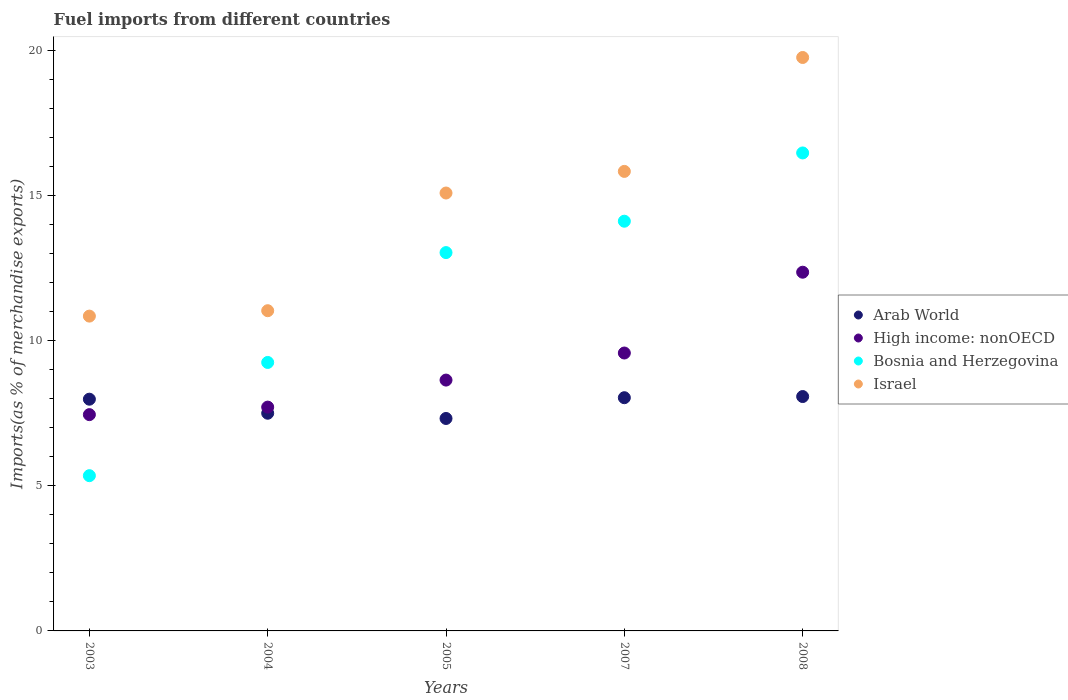Is the number of dotlines equal to the number of legend labels?
Provide a short and direct response. Yes. What is the percentage of imports to different countries in Arab World in 2003?
Offer a terse response. 7.98. Across all years, what is the maximum percentage of imports to different countries in Arab World?
Give a very brief answer. 8.07. Across all years, what is the minimum percentage of imports to different countries in Israel?
Make the answer very short. 10.85. In which year was the percentage of imports to different countries in Israel maximum?
Your answer should be very brief. 2008. In which year was the percentage of imports to different countries in Bosnia and Herzegovina minimum?
Your response must be concise. 2003. What is the total percentage of imports to different countries in High income: nonOECD in the graph?
Provide a succinct answer. 45.73. What is the difference between the percentage of imports to different countries in Arab World in 2004 and that in 2005?
Your answer should be compact. 0.18. What is the difference between the percentage of imports to different countries in Israel in 2005 and the percentage of imports to different countries in High income: nonOECD in 2008?
Offer a very short reply. 2.73. What is the average percentage of imports to different countries in Israel per year?
Your answer should be compact. 14.51. In the year 2005, what is the difference between the percentage of imports to different countries in Israel and percentage of imports to different countries in Arab World?
Make the answer very short. 7.77. In how many years, is the percentage of imports to different countries in High income: nonOECD greater than 15 %?
Offer a very short reply. 0. What is the ratio of the percentage of imports to different countries in Bosnia and Herzegovina in 2003 to that in 2008?
Your answer should be very brief. 0.32. What is the difference between the highest and the second highest percentage of imports to different countries in Israel?
Provide a succinct answer. 3.92. What is the difference between the highest and the lowest percentage of imports to different countries in Israel?
Your answer should be very brief. 8.91. In how many years, is the percentage of imports to different countries in Israel greater than the average percentage of imports to different countries in Israel taken over all years?
Offer a terse response. 3. Is the sum of the percentage of imports to different countries in Bosnia and Herzegovina in 2004 and 2005 greater than the maximum percentage of imports to different countries in Israel across all years?
Keep it short and to the point. Yes. Is it the case that in every year, the sum of the percentage of imports to different countries in Israel and percentage of imports to different countries in High income: nonOECD  is greater than the sum of percentage of imports to different countries in Bosnia and Herzegovina and percentage of imports to different countries in Arab World?
Provide a short and direct response. Yes. Is the percentage of imports to different countries in Arab World strictly less than the percentage of imports to different countries in High income: nonOECD over the years?
Offer a very short reply. No. How many dotlines are there?
Keep it short and to the point. 4. Are the values on the major ticks of Y-axis written in scientific E-notation?
Your response must be concise. No. Does the graph contain any zero values?
Your answer should be compact. No. Where does the legend appear in the graph?
Your answer should be very brief. Center right. How are the legend labels stacked?
Ensure brevity in your answer.  Vertical. What is the title of the graph?
Offer a terse response. Fuel imports from different countries. What is the label or title of the X-axis?
Ensure brevity in your answer.  Years. What is the label or title of the Y-axis?
Give a very brief answer. Imports(as % of merchandise exports). What is the Imports(as % of merchandise exports) in Arab World in 2003?
Make the answer very short. 7.98. What is the Imports(as % of merchandise exports) of High income: nonOECD in 2003?
Offer a very short reply. 7.45. What is the Imports(as % of merchandise exports) in Bosnia and Herzegovina in 2003?
Make the answer very short. 5.35. What is the Imports(as % of merchandise exports) of Israel in 2003?
Your answer should be very brief. 10.85. What is the Imports(as % of merchandise exports) of Arab World in 2004?
Offer a terse response. 7.5. What is the Imports(as % of merchandise exports) of High income: nonOECD in 2004?
Give a very brief answer. 7.71. What is the Imports(as % of merchandise exports) in Bosnia and Herzegovina in 2004?
Ensure brevity in your answer.  9.25. What is the Imports(as % of merchandise exports) in Israel in 2004?
Provide a short and direct response. 11.03. What is the Imports(as % of merchandise exports) in Arab World in 2005?
Provide a short and direct response. 7.32. What is the Imports(as % of merchandise exports) in High income: nonOECD in 2005?
Offer a terse response. 8.64. What is the Imports(as % of merchandise exports) of Bosnia and Herzegovina in 2005?
Provide a short and direct response. 13.03. What is the Imports(as % of merchandise exports) in Israel in 2005?
Your answer should be very brief. 15.09. What is the Imports(as % of merchandise exports) in Arab World in 2007?
Your answer should be compact. 8.03. What is the Imports(as % of merchandise exports) of High income: nonOECD in 2007?
Your response must be concise. 9.57. What is the Imports(as % of merchandise exports) in Bosnia and Herzegovina in 2007?
Give a very brief answer. 14.11. What is the Imports(as % of merchandise exports) of Israel in 2007?
Ensure brevity in your answer.  15.83. What is the Imports(as % of merchandise exports) in Arab World in 2008?
Your answer should be compact. 8.07. What is the Imports(as % of merchandise exports) in High income: nonOECD in 2008?
Provide a succinct answer. 12.36. What is the Imports(as % of merchandise exports) of Bosnia and Herzegovina in 2008?
Give a very brief answer. 16.47. What is the Imports(as % of merchandise exports) in Israel in 2008?
Keep it short and to the point. 19.76. Across all years, what is the maximum Imports(as % of merchandise exports) of Arab World?
Keep it short and to the point. 8.07. Across all years, what is the maximum Imports(as % of merchandise exports) in High income: nonOECD?
Provide a succinct answer. 12.36. Across all years, what is the maximum Imports(as % of merchandise exports) of Bosnia and Herzegovina?
Your answer should be very brief. 16.47. Across all years, what is the maximum Imports(as % of merchandise exports) of Israel?
Provide a short and direct response. 19.76. Across all years, what is the minimum Imports(as % of merchandise exports) of Arab World?
Make the answer very short. 7.32. Across all years, what is the minimum Imports(as % of merchandise exports) of High income: nonOECD?
Give a very brief answer. 7.45. Across all years, what is the minimum Imports(as % of merchandise exports) in Bosnia and Herzegovina?
Offer a terse response. 5.35. Across all years, what is the minimum Imports(as % of merchandise exports) of Israel?
Ensure brevity in your answer.  10.85. What is the total Imports(as % of merchandise exports) in Arab World in the graph?
Your response must be concise. 38.91. What is the total Imports(as % of merchandise exports) in High income: nonOECD in the graph?
Give a very brief answer. 45.73. What is the total Imports(as % of merchandise exports) of Bosnia and Herzegovina in the graph?
Give a very brief answer. 58.21. What is the total Imports(as % of merchandise exports) in Israel in the graph?
Your answer should be very brief. 72.55. What is the difference between the Imports(as % of merchandise exports) of Arab World in 2003 and that in 2004?
Give a very brief answer. 0.48. What is the difference between the Imports(as % of merchandise exports) in High income: nonOECD in 2003 and that in 2004?
Ensure brevity in your answer.  -0.26. What is the difference between the Imports(as % of merchandise exports) in Bosnia and Herzegovina in 2003 and that in 2004?
Keep it short and to the point. -3.9. What is the difference between the Imports(as % of merchandise exports) in Israel in 2003 and that in 2004?
Ensure brevity in your answer.  -0.19. What is the difference between the Imports(as % of merchandise exports) in Arab World in 2003 and that in 2005?
Your response must be concise. 0.66. What is the difference between the Imports(as % of merchandise exports) of High income: nonOECD in 2003 and that in 2005?
Offer a very short reply. -1.19. What is the difference between the Imports(as % of merchandise exports) in Bosnia and Herzegovina in 2003 and that in 2005?
Your response must be concise. -7.68. What is the difference between the Imports(as % of merchandise exports) in Israel in 2003 and that in 2005?
Your response must be concise. -4.24. What is the difference between the Imports(as % of merchandise exports) in Arab World in 2003 and that in 2007?
Provide a succinct answer. -0.05. What is the difference between the Imports(as % of merchandise exports) in High income: nonOECD in 2003 and that in 2007?
Your response must be concise. -2.12. What is the difference between the Imports(as % of merchandise exports) in Bosnia and Herzegovina in 2003 and that in 2007?
Your answer should be very brief. -8.77. What is the difference between the Imports(as % of merchandise exports) of Israel in 2003 and that in 2007?
Ensure brevity in your answer.  -4.99. What is the difference between the Imports(as % of merchandise exports) of Arab World in 2003 and that in 2008?
Your response must be concise. -0.09. What is the difference between the Imports(as % of merchandise exports) of High income: nonOECD in 2003 and that in 2008?
Your answer should be compact. -4.91. What is the difference between the Imports(as % of merchandise exports) of Bosnia and Herzegovina in 2003 and that in 2008?
Offer a terse response. -11.12. What is the difference between the Imports(as % of merchandise exports) in Israel in 2003 and that in 2008?
Your answer should be compact. -8.91. What is the difference between the Imports(as % of merchandise exports) in Arab World in 2004 and that in 2005?
Your answer should be very brief. 0.18. What is the difference between the Imports(as % of merchandise exports) of High income: nonOECD in 2004 and that in 2005?
Provide a succinct answer. -0.93. What is the difference between the Imports(as % of merchandise exports) of Bosnia and Herzegovina in 2004 and that in 2005?
Offer a very short reply. -3.78. What is the difference between the Imports(as % of merchandise exports) of Israel in 2004 and that in 2005?
Your response must be concise. -4.05. What is the difference between the Imports(as % of merchandise exports) in Arab World in 2004 and that in 2007?
Provide a short and direct response. -0.53. What is the difference between the Imports(as % of merchandise exports) of High income: nonOECD in 2004 and that in 2007?
Keep it short and to the point. -1.86. What is the difference between the Imports(as % of merchandise exports) of Bosnia and Herzegovina in 2004 and that in 2007?
Provide a short and direct response. -4.87. What is the difference between the Imports(as % of merchandise exports) in Israel in 2004 and that in 2007?
Provide a succinct answer. -4.8. What is the difference between the Imports(as % of merchandise exports) of Arab World in 2004 and that in 2008?
Provide a succinct answer. -0.57. What is the difference between the Imports(as % of merchandise exports) in High income: nonOECD in 2004 and that in 2008?
Your response must be concise. -4.65. What is the difference between the Imports(as % of merchandise exports) of Bosnia and Herzegovina in 2004 and that in 2008?
Ensure brevity in your answer.  -7.22. What is the difference between the Imports(as % of merchandise exports) of Israel in 2004 and that in 2008?
Your answer should be very brief. -8.72. What is the difference between the Imports(as % of merchandise exports) of Arab World in 2005 and that in 2007?
Provide a short and direct response. -0.72. What is the difference between the Imports(as % of merchandise exports) of High income: nonOECD in 2005 and that in 2007?
Offer a very short reply. -0.93. What is the difference between the Imports(as % of merchandise exports) of Bosnia and Herzegovina in 2005 and that in 2007?
Offer a terse response. -1.08. What is the difference between the Imports(as % of merchandise exports) of Israel in 2005 and that in 2007?
Make the answer very short. -0.74. What is the difference between the Imports(as % of merchandise exports) in Arab World in 2005 and that in 2008?
Your response must be concise. -0.76. What is the difference between the Imports(as % of merchandise exports) in High income: nonOECD in 2005 and that in 2008?
Your answer should be very brief. -3.72. What is the difference between the Imports(as % of merchandise exports) of Bosnia and Herzegovina in 2005 and that in 2008?
Ensure brevity in your answer.  -3.43. What is the difference between the Imports(as % of merchandise exports) of Israel in 2005 and that in 2008?
Your answer should be compact. -4.67. What is the difference between the Imports(as % of merchandise exports) of Arab World in 2007 and that in 2008?
Offer a very short reply. -0.04. What is the difference between the Imports(as % of merchandise exports) of High income: nonOECD in 2007 and that in 2008?
Provide a succinct answer. -2.78. What is the difference between the Imports(as % of merchandise exports) in Bosnia and Herzegovina in 2007 and that in 2008?
Your answer should be compact. -2.35. What is the difference between the Imports(as % of merchandise exports) in Israel in 2007 and that in 2008?
Make the answer very short. -3.92. What is the difference between the Imports(as % of merchandise exports) of Arab World in 2003 and the Imports(as % of merchandise exports) of High income: nonOECD in 2004?
Ensure brevity in your answer.  0.27. What is the difference between the Imports(as % of merchandise exports) of Arab World in 2003 and the Imports(as % of merchandise exports) of Bosnia and Herzegovina in 2004?
Ensure brevity in your answer.  -1.27. What is the difference between the Imports(as % of merchandise exports) of Arab World in 2003 and the Imports(as % of merchandise exports) of Israel in 2004?
Keep it short and to the point. -3.05. What is the difference between the Imports(as % of merchandise exports) in High income: nonOECD in 2003 and the Imports(as % of merchandise exports) in Bosnia and Herzegovina in 2004?
Offer a terse response. -1.8. What is the difference between the Imports(as % of merchandise exports) in High income: nonOECD in 2003 and the Imports(as % of merchandise exports) in Israel in 2004?
Ensure brevity in your answer.  -3.58. What is the difference between the Imports(as % of merchandise exports) of Bosnia and Herzegovina in 2003 and the Imports(as % of merchandise exports) of Israel in 2004?
Provide a succinct answer. -5.68. What is the difference between the Imports(as % of merchandise exports) of Arab World in 2003 and the Imports(as % of merchandise exports) of High income: nonOECD in 2005?
Offer a very short reply. -0.66. What is the difference between the Imports(as % of merchandise exports) of Arab World in 2003 and the Imports(as % of merchandise exports) of Bosnia and Herzegovina in 2005?
Offer a very short reply. -5.05. What is the difference between the Imports(as % of merchandise exports) of Arab World in 2003 and the Imports(as % of merchandise exports) of Israel in 2005?
Provide a succinct answer. -7.1. What is the difference between the Imports(as % of merchandise exports) in High income: nonOECD in 2003 and the Imports(as % of merchandise exports) in Bosnia and Herzegovina in 2005?
Make the answer very short. -5.58. What is the difference between the Imports(as % of merchandise exports) in High income: nonOECD in 2003 and the Imports(as % of merchandise exports) in Israel in 2005?
Provide a succinct answer. -7.63. What is the difference between the Imports(as % of merchandise exports) in Bosnia and Herzegovina in 2003 and the Imports(as % of merchandise exports) in Israel in 2005?
Provide a short and direct response. -9.74. What is the difference between the Imports(as % of merchandise exports) in Arab World in 2003 and the Imports(as % of merchandise exports) in High income: nonOECD in 2007?
Provide a succinct answer. -1.59. What is the difference between the Imports(as % of merchandise exports) in Arab World in 2003 and the Imports(as % of merchandise exports) in Bosnia and Herzegovina in 2007?
Your answer should be compact. -6.13. What is the difference between the Imports(as % of merchandise exports) in Arab World in 2003 and the Imports(as % of merchandise exports) in Israel in 2007?
Ensure brevity in your answer.  -7.85. What is the difference between the Imports(as % of merchandise exports) in High income: nonOECD in 2003 and the Imports(as % of merchandise exports) in Bosnia and Herzegovina in 2007?
Provide a succinct answer. -6.66. What is the difference between the Imports(as % of merchandise exports) in High income: nonOECD in 2003 and the Imports(as % of merchandise exports) in Israel in 2007?
Give a very brief answer. -8.38. What is the difference between the Imports(as % of merchandise exports) of Bosnia and Herzegovina in 2003 and the Imports(as % of merchandise exports) of Israel in 2007?
Offer a very short reply. -10.48. What is the difference between the Imports(as % of merchandise exports) in Arab World in 2003 and the Imports(as % of merchandise exports) in High income: nonOECD in 2008?
Your response must be concise. -4.37. What is the difference between the Imports(as % of merchandise exports) of Arab World in 2003 and the Imports(as % of merchandise exports) of Bosnia and Herzegovina in 2008?
Your response must be concise. -8.48. What is the difference between the Imports(as % of merchandise exports) in Arab World in 2003 and the Imports(as % of merchandise exports) in Israel in 2008?
Keep it short and to the point. -11.77. What is the difference between the Imports(as % of merchandise exports) of High income: nonOECD in 2003 and the Imports(as % of merchandise exports) of Bosnia and Herzegovina in 2008?
Provide a short and direct response. -9.02. What is the difference between the Imports(as % of merchandise exports) in High income: nonOECD in 2003 and the Imports(as % of merchandise exports) in Israel in 2008?
Your answer should be very brief. -12.3. What is the difference between the Imports(as % of merchandise exports) of Bosnia and Herzegovina in 2003 and the Imports(as % of merchandise exports) of Israel in 2008?
Offer a terse response. -14.41. What is the difference between the Imports(as % of merchandise exports) in Arab World in 2004 and the Imports(as % of merchandise exports) in High income: nonOECD in 2005?
Provide a short and direct response. -1.14. What is the difference between the Imports(as % of merchandise exports) in Arab World in 2004 and the Imports(as % of merchandise exports) in Bosnia and Herzegovina in 2005?
Make the answer very short. -5.53. What is the difference between the Imports(as % of merchandise exports) in Arab World in 2004 and the Imports(as % of merchandise exports) in Israel in 2005?
Give a very brief answer. -7.59. What is the difference between the Imports(as % of merchandise exports) of High income: nonOECD in 2004 and the Imports(as % of merchandise exports) of Bosnia and Herzegovina in 2005?
Your answer should be compact. -5.32. What is the difference between the Imports(as % of merchandise exports) in High income: nonOECD in 2004 and the Imports(as % of merchandise exports) in Israel in 2005?
Ensure brevity in your answer.  -7.38. What is the difference between the Imports(as % of merchandise exports) of Bosnia and Herzegovina in 2004 and the Imports(as % of merchandise exports) of Israel in 2005?
Your response must be concise. -5.84. What is the difference between the Imports(as % of merchandise exports) in Arab World in 2004 and the Imports(as % of merchandise exports) in High income: nonOECD in 2007?
Your answer should be very brief. -2.07. What is the difference between the Imports(as % of merchandise exports) of Arab World in 2004 and the Imports(as % of merchandise exports) of Bosnia and Herzegovina in 2007?
Give a very brief answer. -6.62. What is the difference between the Imports(as % of merchandise exports) in Arab World in 2004 and the Imports(as % of merchandise exports) in Israel in 2007?
Your answer should be compact. -8.33. What is the difference between the Imports(as % of merchandise exports) of High income: nonOECD in 2004 and the Imports(as % of merchandise exports) of Bosnia and Herzegovina in 2007?
Offer a very short reply. -6.4. What is the difference between the Imports(as % of merchandise exports) of High income: nonOECD in 2004 and the Imports(as % of merchandise exports) of Israel in 2007?
Provide a succinct answer. -8.12. What is the difference between the Imports(as % of merchandise exports) in Bosnia and Herzegovina in 2004 and the Imports(as % of merchandise exports) in Israel in 2007?
Give a very brief answer. -6.58. What is the difference between the Imports(as % of merchandise exports) of Arab World in 2004 and the Imports(as % of merchandise exports) of High income: nonOECD in 2008?
Make the answer very short. -4.86. What is the difference between the Imports(as % of merchandise exports) of Arab World in 2004 and the Imports(as % of merchandise exports) of Bosnia and Herzegovina in 2008?
Your answer should be very brief. -8.97. What is the difference between the Imports(as % of merchandise exports) of Arab World in 2004 and the Imports(as % of merchandise exports) of Israel in 2008?
Ensure brevity in your answer.  -12.26. What is the difference between the Imports(as % of merchandise exports) of High income: nonOECD in 2004 and the Imports(as % of merchandise exports) of Bosnia and Herzegovina in 2008?
Your answer should be compact. -8.76. What is the difference between the Imports(as % of merchandise exports) of High income: nonOECD in 2004 and the Imports(as % of merchandise exports) of Israel in 2008?
Offer a very short reply. -12.04. What is the difference between the Imports(as % of merchandise exports) of Bosnia and Herzegovina in 2004 and the Imports(as % of merchandise exports) of Israel in 2008?
Make the answer very short. -10.51. What is the difference between the Imports(as % of merchandise exports) in Arab World in 2005 and the Imports(as % of merchandise exports) in High income: nonOECD in 2007?
Your response must be concise. -2.25. What is the difference between the Imports(as % of merchandise exports) in Arab World in 2005 and the Imports(as % of merchandise exports) in Bosnia and Herzegovina in 2007?
Offer a terse response. -6.8. What is the difference between the Imports(as % of merchandise exports) in Arab World in 2005 and the Imports(as % of merchandise exports) in Israel in 2007?
Ensure brevity in your answer.  -8.51. What is the difference between the Imports(as % of merchandise exports) of High income: nonOECD in 2005 and the Imports(as % of merchandise exports) of Bosnia and Herzegovina in 2007?
Offer a terse response. -5.47. What is the difference between the Imports(as % of merchandise exports) in High income: nonOECD in 2005 and the Imports(as % of merchandise exports) in Israel in 2007?
Keep it short and to the point. -7.19. What is the difference between the Imports(as % of merchandise exports) in Bosnia and Herzegovina in 2005 and the Imports(as % of merchandise exports) in Israel in 2007?
Offer a terse response. -2.8. What is the difference between the Imports(as % of merchandise exports) in Arab World in 2005 and the Imports(as % of merchandise exports) in High income: nonOECD in 2008?
Keep it short and to the point. -5.04. What is the difference between the Imports(as % of merchandise exports) in Arab World in 2005 and the Imports(as % of merchandise exports) in Bosnia and Herzegovina in 2008?
Ensure brevity in your answer.  -9.15. What is the difference between the Imports(as % of merchandise exports) in Arab World in 2005 and the Imports(as % of merchandise exports) in Israel in 2008?
Make the answer very short. -12.44. What is the difference between the Imports(as % of merchandise exports) of High income: nonOECD in 2005 and the Imports(as % of merchandise exports) of Bosnia and Herzegovina in 2008?
Your response must be concise. -7.82. What is the difference between the Imports(as % of merchandise exports) of High income: nonOECD in 2005 and the Imports(as % of merchandise exports) of Israel in 2008?
Your response must be concise. -11.11. What is the difference between the Imports(as % of merchandise exports) of Bosnia and Herzegovina in 2005 and the Imports(as % of merchandise exports) of Israel in 2008?
Your response must be concise. -6.72. What is the difference between the Imports(as % of merchandise exports) in Arab World in 2007 and the Imports(as % of merchandise exports) in High income: nonOECD in 2008?
Keep it short and to the point. -4.32. What is the difference between the Imports(as % of merchandise exports) of Arab World in 2007 and the Imports(as % of merchandise exports) of Bosnia and Herzegovina in 2008?
Offer a terse response. -8.43. What is the difference between the Imports(as % of merchandise exports) in Arab World in 2007 and the Imports(as % of merchandise exports) in Israel in 2008?
Offer a terse response. -11.72. What is the difference between the Imports(as % of merchandise exports) in High income: nonOECD in 2007 and the Imports(as % of merchandise exports) in Bosnia and Herzegovina in 2008?
Make the answer very short. -6.89. What is the difference between the Imports(as % of merchandise exports) in High income: nonOECD in 2007 and the Imports(as % of merchandise exports) in Israel in 2008?
Give a very brief answer. -10.18. What is the difference between the Imports(as % of merchandise exports) in Bosnia and Herzegovina in 2007 and the Imports(as % of merchandise exports) in Israel in 2008?
Provide a short and direct response. -5.64. What is the average Imports(as % of merchandise exports) of Arab World per year?
Ensure brevity in your answer.  7.78. What is the average Imports(as % of merchandise exports) of High income: nonOECD per year?
Give a very brief answer. 9.15. What is the average Imports(as % of merchandise exports) of Bosnia and Herzegovina per year?
Make the answer very short. 11.64. What is the average Imports(as % of merchandise exports) of Israel per year?
Your response must be concise. 14.51. In the year 2003, what is the difference between the Imports(as % of merchandise exports) of Arab World and Imports(as % of merchandise exports) of High income: nonOECD?
Your answer should be compact. 0.53. In the year 2003, what is the difference between the Imports(as % of merchandise exports) in Arab World and Imports(as % of merchandise exports) in Bosnia and Herzegovina?
Your response must be concise. 2.63. In the year 2003, what is the difference between the Imports(as % of merchandise exports) of Arab World and Imports(as % of merchandise exports) of Israel?
Offer a terse response. -2.86. In the year 2003, what is the difference between the Imports(as % of merchandise exports) in High income: nonOECD and Imports(as % of merchandise exports) in Bosnia and Herzegovina?
Provide a succinct answer. 2.1. In the year 2003, what is the difference between the Imports(as % of merchandise exports) in High income: nonOECD and Imports(as % of merchandise exports) in Israel?
Keep it short and to the point. -3.39. In the year 2003, what is the difference between the Imports(as % of merchandise exports) of Bosnia and Herzegovina and Imports(as % of merchandise exports) of Israel?
Your answer should be compact. -5.5. In the year 2004, what is the difference between the Imports(as % of merchandise exports) in Arab World and Imports(as % of merchandise exports) in High income: nonOECD?
Keep it short and to the point. -0.21. In the year 2004, what is the difference between the Imports(as % of merchandise exports) in Arab World and Imports(as % of merchandise exports) in Bosnia and Herzegovina?
Your answer should be very brief. -1.75. In the year 2004, what is the difference between the Imports(as % of merchandise exports) of Arab World and Imports(as % of merchandise exports) of Israel?
Your answer should be very brief. -3.53. In the year 2004, what is the difference between the Imports(as % of merchandise exports) in High income: nonOECD and Imports(as % of merchandise exports) in Bosnia and Herzegovina?
Your answer should be very brief. -1.54. In the year 2004, what is the difference between the Imports(as % of merchandise exports) of High income: nonOECD and Imports(as % of merchandise exports) of Israel?
Offer a terse response. -3.32. In the year 2004, what is the difference between the Imports(as % of merchandise exports) of Bosnia and Herzegovina and Imports(as % of merchandise exports) of Israel?
Make the answer very short. -1.78. In the year 2005, what is the difference between the Imports(as % of merchandise exports) in Arab World and Imports(as % of merchandise exports) in High income: nonOECD?
Your response must be concise. -1.32. In the year 2005, what is the difference between the Imports(as % of merchandise exports) of Arab World and Imports(as % of merchandise exports) of Bosnia and Herzegovina?
Offer a very short reply. -5.71. In the year 2005, what is the difference between the Imports(as % of merchandise exports) in Arab World and Imports(as % of merchandise exports) in Israel?
Your answer should be very brief. -7.77. In the year 2005, what is the difference between the Imports(as % of merchandise exports) in High income: nonOECD and Imports(as % of merchandise exports) in Bosnia and Herzegovina?
Keep it short and to the point. -4.39. In the year 2005, what is the difference between the Imports(as % of merchandise exports) in High income: nonOECD and Imports(as % of merchandise exports) in Israel?
Keep it short and to the point. -6.44. In the year 2005, what is the difference between the Imports(as % of merchandise exports) in Bosnia and Herzegovina and Imports(as % of merchandise exports) in Israel?
Your answer should be compact. -2.05. In the year 2007, what is the difference between the Imports(as % of merchandise exports) in Arab World and Imports(as % of merchandise exports) in High income: nonOECD?
Your answer should be compact. -1.54. In the year 2007, what is the difference between the Imports(as % of merchandise exports) in Arab World and Imports(as % of merchandise exports) in Bosnia and Herzegovina?
Make the answer very short. -6.08. In the year 2007, what is the difference between the Imports(as % of merchandise exports) in Arab World and Imports(as % of merchandise exports) in Israel?
Make the answer very short. -7.8. In the year 2007, what is the difference between the Imports(as % of merchandise exports) in High income: nonOECD and Imports(as % of merchandise exports) in Bosnia and Herzegovina?
Offer a very short reply. -4.54. In the year 2007, what is the difference between the Imports(as % of merchandise exports) of High income: nonOECD and Imports(as % of merchandise exports) of Israel?
Provide a short and direct response. -6.26. In the year 2007, what is the difference between the Imports(as % of merchandise exports) of Bosnia and Herzegovina and Imports(as % of merchandise exports) of Israel?
Make the answer very short. -1.72. In the year 2008, what is the difference between the Imports(as % of merchandise exports) of Arab World and Imports(as % of merchandise exports) of High income: nonOECD?
Your answer should be very brief. -4.28. In the year 2008, what is the difference between the Imports(as % of merchandise exports) of Arab World and Imports(as % of merchandise exports) of Bosnia and Herzegovina?
Ensure brevity in your answer.  -8.39. In the year 2008, what is the difference between the Imports(as % of merchandise exports) of Arab World and Imports(as % of merchandise exports) of Israel?
Make the answer very short. -11.68. In the year 2008, what is the difference between the Imports(as % of merchandise exports) in High income: nonOECD and Imports(as % of merchandise exports) in Bosnia and Herzegovina?
Your response must be concise. -4.11. In the year 2008, what is the difference between the Imports(as % of merchandise exports) in High income: nonOECD and Imports(as % of merchandise exports) in Israel?
Ensure brevity in your answer.  -7.4. In the year 2008, what is the difference between the Imports(as % of merchandise exports) in Bosnia and Herzegovina and Imports(as % of merchandise exports) in Israel?
Your response must be concise. -3.29. What is the ratio of the Imports(as % of merchandise exports) in Arab World in 2003 to that in 2004?
Give a very brief answer. 1.06. What is the ratio of the Imports(as % of merchandise exports) in High income: nonOECD in 2003 to that in 2004?
Your response must be concise. 0.97. What is the ratio of the Imports(as % of merchandise exports) of Bosnia and Herzegovina in 2003 to that in 2004?
Your response must be concise. 0.58. What is the ratio of the Imports(as % of merchandise exports) of Israel in 2003 to that in 2004?
Ensure brevity in your answer.  0.98. What is the ratio of the Imports(as % of merchandise exports) of Arab World in 2003 to that in 2005?
Offer a very short reply. 1.09. What is the ratio of the Imports(as % of merchandise exports) in High income: nonOECD in 2003 to that in 2005?
Give a very brief answer. 0.86. What is the ratio of the Imports(as % of merchandise exports) in Bosnia and Herzegovina in 2003 to that in 2005?
Ensure brevity in your answer.  0.41. What is the ratio of the Imports(as % of merchandise exports) in Israel in 2003 to that in 2005?
Make the answer very short. 0.72. What is the ratio of the Imports(as % of merchandise exports) of Arab World in 2003 to that in 2007?
Make the answer very short. 0.99. What is the ratio of the Imports(as % of merchandise exports) of High income: nonOECD in 2003 to that in 2007?
Provide a succinct answer. 0.78. What is the ratio of the Imports(as % of merchandise exports) of Bosnia and Herzegovina in 2003 to that in 2007?
Your response must be concise. 0.38. What is the ratio of the Imports(as % of merchandise exports) of Israel in 2003 to that in 2007?
Provide a succinct answer. 0.69. What is the ratio of the Imports(as % of merchandise exports) in Arab World in 2003 to that in 2008?
Ensure brevity in your answer.  0.99. What is the ratio of the Imports(as % of merchandise exports) in High income: nonOECD in 2003 to that in 2008?
Offer a very short reply. 0.6. What is the ratio of the Imports(as % of merchandise exports) of Bosnia and Herzegovina in 2003 to that in 2008?
Your answer should be very brief. 0.32. What is the ratio of the Imports(as % of merchandise exports) of Israel in 2003 to that in 2008?
Your response must be concise. 0.55. What is the ratio of the Imports(as % of merchandise exports) of Arab World in 2004 to that in 2005?
Provide a short and direct response. 1.02. What is the ratio of the Imports(as % of merchandise exports) in High income: nonOECD in 2004 to that in 2005?
Keep it short and to the point. 0.89. What is the ratio of the Imports(as % of merchandise exports) in Bosnia and Herzegovina in 2004 to that in 2005?
Provide a succinct answer. 0.71. What is the ratio of the Imports(as % of merchandise exports) in Israel in 2004 to that in 2005?
Offer a very short reply. 0.73. What is the ratio of the Imports(as % of merchandise exports) in Arab World in 2004 to that in 2007?
Offer a very short reply. 0.93. What is the ratio of the Imports(as % of merchandise exports) of High income: nonOECD in 2004 to that in 2007?
Provide a succinct answer. 0.81. What is the ratio of the Imports(as % of merchandise exports) of Bosnia and Herzegovina in 2004 to that in 2007?
Ensure brevity in your answer.  0.66. What is the ratio of the Imports(as % of merchandise exports) in Israel in 2004 to that in 2007?
Offer a very short reply. 0.7. What is the ratio of the Imports(as % of merchandise exports) of Arab World in 2004 to that in 2008?
Ensure brevity in your answer.  0.93. What is the ratio of the Imports(as % of merchandise exports) in High income: nonOECD in 2004 to that in 2008?
Offer a very short reply. 0.62. What is the ratio of the Imports(as % of merchandise exports) in Bosnia and Herzegovina in 2004 to that in 2008?
Your answer should be very brief. 0.56. What is the ratio of the Imports(as % of merchandise exports) in Israel in 2004 to that in 2008?
Offer a very short reply. 0.56. What is the ratio of the Imports(as % of merchandise exports) in Arab World in 2005 to that in 2007?
Offer a very short reply. 0.91. What is the ratio of the Imports(as % of merchandise exports) in High income: nonOECD in 2005 to that in 2007?
Keep it short and to the point. 0.9. What is the ratio of the Imports(as % of merchandise exports) in Bosnia and Herzegovina in 2005 to that in 2007?
Keep it short and to the point. 0.92. What is the ratio of the Imports(as % of merchandise exports) in Israel in 2005 to that in 2007?
Offer a very short reply. 0.95. What is the ratio of the Imports(as % of merchandise exports) in Arab World in 2005 to that in 2008?
Your answer should be very brief. 0.91. What is the ratio of the Imports(as % of merchandise exports) in High income: nonOECD in 2005 to that in 2008?
Give a very brief answer. 0.7. What is the ratio of the Imports(as % of merchandise exports) in Bosnia and Herzegovina in 2005 to that in 2008?
Offer a terse response. 0.79. What is the ratio of the Imports(as % of merchandise exports) in Israel in 2005 to that in 2008?
Offer a terse response. 0.76. What is the ratio of the Imports(as % of merchandise exports) in Arab World in 2007 to that in 2008?
Offer a terse response. 0.99. What is the ratio of the Imports(as % of merchandise exports) of High income: nonOECD in 2007 to that in 2008?
Offer a terse response. 0.77. What is the ratio of the Imports(as % of merchandise exports) of Bosnia and Herzegovina in 2007 to that in 2008?
Give a very brief answer. 0.86. What is the ratio of the Imports(as % of merchandise exports) in Israel in 2007 to that in 2008?
Your answer should be compact. 0.8. What is the difference between the highest and the second highest Imports(as % of merchandise exports) of Arab World?
Offer a terse response. 0.04. What is the difference between the highest and the second highest Imports(as % of merchandise exports) of High income: nonOECD?
Provide a succinct answer. 2.78. What is the difference between the highest and the second highest Imports(as % of merchandise exports) of Bosnia and Herzegovina?
Your answer should be very brief. 2.35. What is the difference between the highest and the second highest Imports(as % of merchandise exports) of Israel?
Offer a terse response. 3.92. What is the difference between the highest and the lowest Imports(as % of merchandise exports) in Arab World?
Give a very brief answer. 0.76. What is the difference between the highest and the lowest Imports(as % of merchandise exports) of High income: nonOECD?
Provide a short and direct response. 4.91. What is the difference between the highest and the lowest Imports(as % of merchandise exports) of Bosnia and Herzegovina?
Your response must be concise. 11.12. What is the difference between the highest and the lowest Imports(as % of merchandise exports) in Israel?
Your answer should be compact. 8.91. 